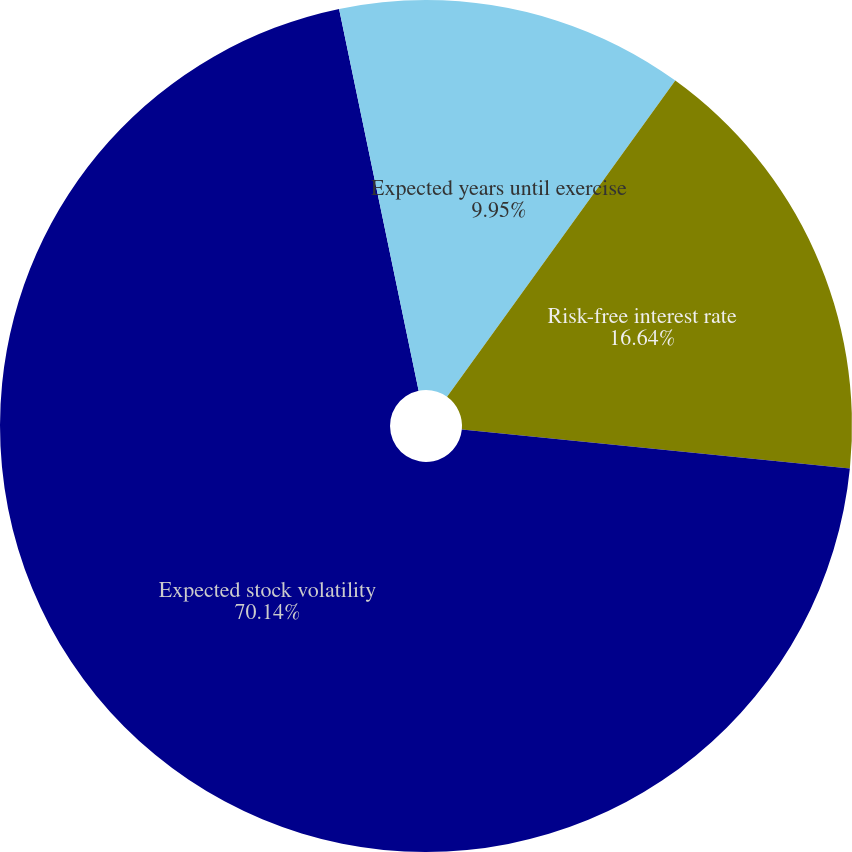<chart> <loc_0><loc_0><loc_500><loc_500><pie_chart><fcel>Expected years until exercise<fcel>Risk-free interest rate<fcel>Expected stock volatility<fcel>Expected dividend yield<nl><fcel>9.95%<fcel>16.64%<fcel>70.14%<fcel>3.27%<nl></chart> 